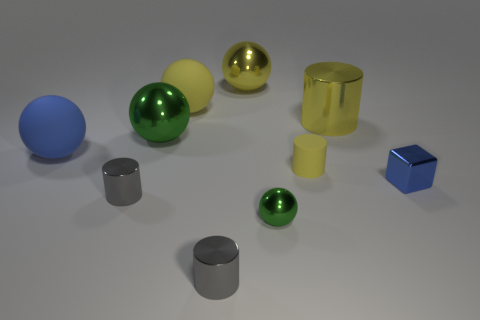There is a big metallic cylinder; what number of blue things are to the left of it?
Your response must be concise. 1. There is a blue thing that is behind the tiny cylinder to the right of the tiny green ball; what is its shape?
Provide a succinct answer. Sphere. There is a big yellow thing that is the same material as the blue sphere; what is its shape?
Give a very brief answer. Sphere. There is a yellow shiny thing that is on the left side of the big yellow metallic cylinder; is its size the same as the cylinder that is on the right side of the matte cylinder?
Your answer should be compact. Yes. There is a green shiny object that is in front of the tiny blue block; what shape is it?
Provide a succinct answer. Sphere. What is the color of the tiny cube?
Your answer should be very brief. Blue. There is a yellow rubber cylinder; does it have the same size as the green metal sphere in front of the blue matte sphere?
Provide a succinct answer. Yes. How many shiny things are big blue cubes or small gray things?
Your answer should be compact. 2. There is a matte cylinder; is its color the same as the big metallic ball that is behind the large cylinder?
Your answer should be very brief. Yes. There is a big green metal object; what shape is it?
Offer a terse response. Sphere. 